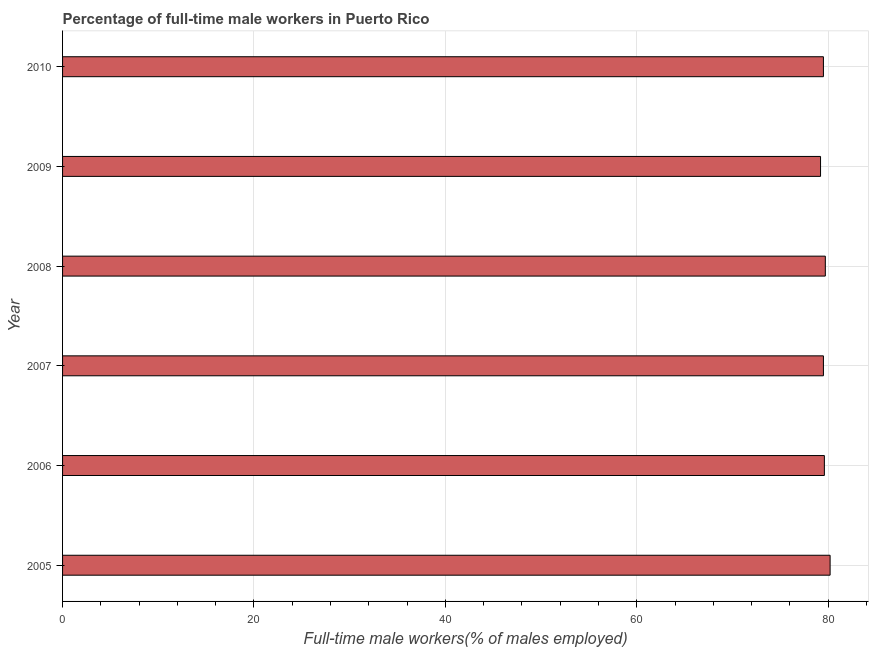What is the title of the graph?
Provide a succinct answer. Percentage of full-time male workers in Puerto Rico. What is the label or title of the X-axis?
Ensure brevity in your answer.  Full-time male workers(% of males employed). What is the percentage of full-time male workers in 2008?
Your response must be concise. 79.7. Across all years, what is the maximum percentage of full-time male workers?
Ensure brevity in your answer.  80.2. Across all years, what is the minimum percentage of full-time male workers?
Your answer should be compact. 79.2. In which year was the percentage of full-time male workers minimum?
Offer a terse response. 2009. What is the sum of the percentage of full-time male workers?
Make the answer very short. 477.7. What is the average percentage of full-time male workers per year?
Provide a succinct answer. 79.62. What is the median percentage of full-time male workers?
Offer a very short reply. 79.55. Is the difference between the percentage of full-time male workers in 2006 and 2008 greater than the difference between any two years?
Make the answer very short. No. Is the sum of the percentage of full-time male workers in 2006 and 2007 greater than the maximum percentage of full-time male workers across all years?
Provide a short and direct response. Yes. Are all the bars in the graph horizontal?
Your answer should be compact. Yes. What is the difference between two consecutive major ticks on the X-axis?
Provide a succinct answer. 20. What is the Full-time male workers(% of males employed) of 2005?
Keep it short and to the point. 80.2. What is the Full-time male workers(% of males employed) of 2006?
Provide a succinct answer. 79.6. What is the Full-time male workers(% of males employed) in 2007?
Ensure brevity in your answer.  79.5. What is the Full-time male workers(% of males employed) in 2008?
Keep it short and to the point. 79.7. What is the Full-time male workers(% of males employed) in 2009?
Offer a terse response. 79.2. What is the Full-time male workers(% of males employed) in 2010?
Offer a very short reply. 79.5. What is the difference between the Full-time male workers(% of males employed) in 2005 and 2006?
Your answer should be very brief. 0.6. What is the difference between the Full-time male workers(% of males employed) in 2005 and 2007?
Provide a short and direct response. 0.7. What is the difference between the Full-time male workers(% of males employed) in 2005 and 2009?
Make the answer very short. 1. What is the difference between the Full-time male workers(% of males employed) in 2005 and 2010?
Offer a terse response. 0.7. What is the difference between the Full-time male workers(% of males employed) in 2006 and 2007?
Provide a short and direct response. 0.1. What is the difference between the Full-time male workers(% of males employed) in 2006 and 2009?
Offer a terse response. 0.4. What is the difference between the Full-time male workers(% of males employed) in 2008 and 2010?
Make the answer very short. 0.2. What is the difference between the Full-time male workers(% of males employed) in 2009 and 2010?
Ensure brevity in your answer.  -0.3. What is the ratio of the Full-time male workers(% of males employed) in 2005 to that in 2006?
Provide a short and direct response. 1.01. What is the ratio of the Full-time male workers(% of males employed) in 2005 to that in 2010?
Keep it short and to the point. 1.01. What is the ratio of the Full-time male workers(% of males employed) in 2006 to that in 2007?
Give a very brief answer. 1. What is the ratio of the Full-time male workers(% of males employed) in 2006 to that in 2009?
Offer a very short reply. 1. What is the ratio of the Full-time male workers(% of males employed) in 2006 to that in 2010?
Your answer should be very brief. 1. What is the ratio of the Full-time male workers(% of males employed) in 2007 to that in 2008?
Give a very brief answer. 1. What is the ratio of the Full-time male workers(% of males employed) in 2007 to that in 2009?
Give a very brief answer. 1. What is the ratio of the Full-time male workers(% of males employed) in 2008 to that in 2010?
Keep it short and to the point. 1. 